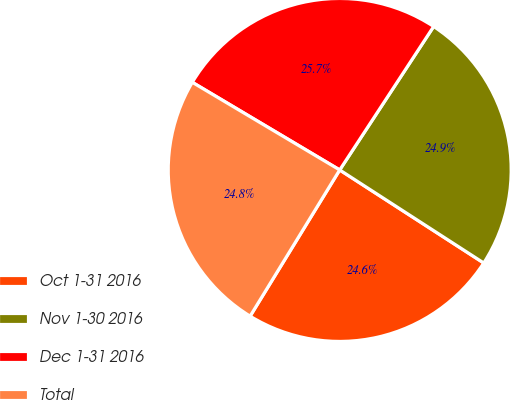<chart> <loc_0><loc_0><loc_500><loc_500><pie_chart><fcel>Oct 1-31 2016<fcel>Nov 1-30 2016<fcel>Dec 1-31 2016<fcel>Total<nl><fcel>24.62%<fcel>24.9%<fcel>25.69%<fcel>24.79%<nl></chart> 